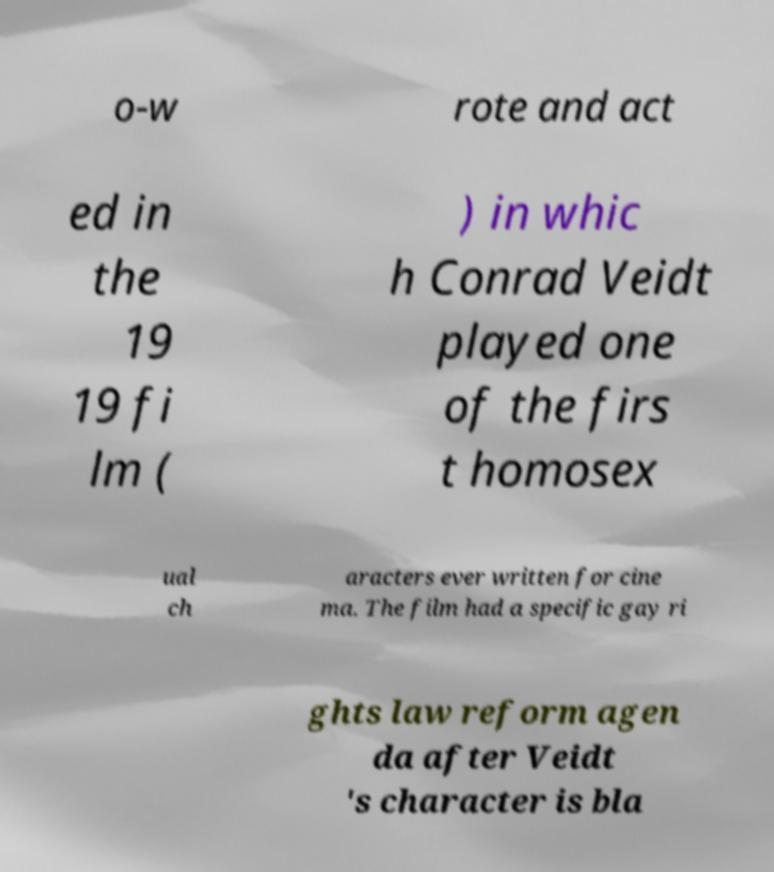What messages or text are displayed in this image? I need them in a readable, typed format. o-w rote and act ed in the 19 19 fi lm ( ) in whic h Conrad Veidt played one of the firs t homosex ual ch aracters ever written for cine ma. The film had a specific gay ri ghts law reform agen da after Veidt 's character is bla 